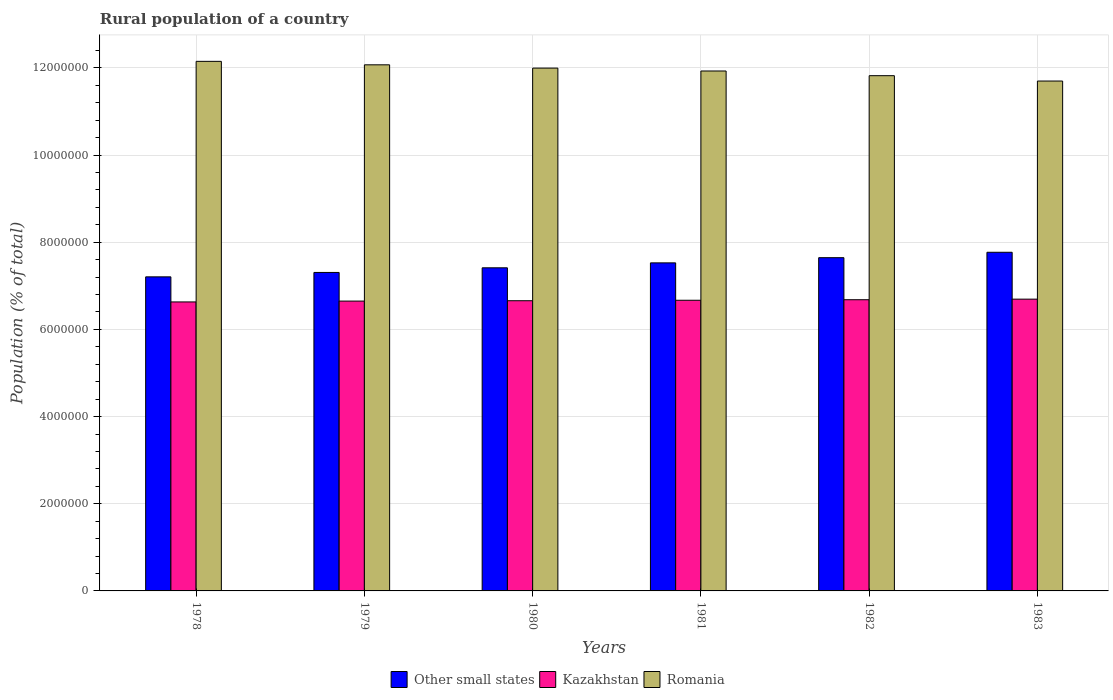How many groups of bars are there?
Make the answer very short. 6. Are the number of bars per tick equal to the number of legend labels?
Your response must be concise. Yes. What is the rural population in Other small states in 1982?
Your answer should be very brief. 7.65e+06. Across all years, what is the maximum rural population in Kazakhstan?
Provide a short and direct response. 6.69e+06. Across all years, what is the minimum rural population in Kazakhstan?
Offer a very short reply. 6.63e+06. In which year was the rural population in Other small states maximum?
Give a very brief answer. 1983. In which year was the rural population in Other small states minimum?
Your response must be concise. 1978. What is the total rural population in Kazakhstan in the graph?
Make the answer very short. 4.00e+07. What is the difference between the rural population in Romania in 1978 and that in 1979?
Ensure brevity in your answer.  7.97e+04. What is the difference between the rural population in Kazakhstan in 1981 and the rural population in Other small states in 1978?
Provide a succinct answer. -5.37e+05. What is the average rural population in Kazakhstan per year?
Offer a very short reply. 6.66e+06. In the year 1981, what is the difference between the rural population in Kazakhstan and rural population in Romania?
Ensure brevity in your answer.  -5.26e+06. In how many years, is the rural population in Kazakhstan greater than 400000 %?
Keep it short and to the point. 6. What is the ratio of the rural population in Other small states in 1979 to that in 1982?
Keep it short and to the point. 0.96. Is the rural population in Romania in 1978 less than that in 1983?
Give a very brief answer. No. Is the difference between the rural population in Kazakhstan in 1981 and 1982 greater than the difference between the rural population in Romania in 1981 and 1982?
Provide a short and direct response. No. What is the difference between the highest and the second highest rural population in Kazakhstan?
Make the answer very short. 1.34e+04. What is the difference between the highest and the lowest rural population in Romania?
Give a very brief answer. 4.52e+05. What does the 2nd bar from the left in 1983 represents?
Keep it short and to the point. Kazakhstan. What does the 1st bar from the right in 1983 represents?
Offer a very short reply. Romania. Does the graph contain any zero values?
Make the answer very short. No. Does the graph contain grids?
Provide a succinct answer. Yes. Where does the legend appear in the graph?
Ensure brevity in your answer.  Bottom center. How many legend labels are there?
Your answer should be very brief. 3. How are the legend labels stacked?
Offer a very short reply. Horizontal. What is the title of the graph?
Ensure brevity in your answer.  Rural population of a country. What is the label or title of the X-axis?
Make the answer very short. Years. What is the label or title of the Y-axis?
Your answer should be compact. Population (% of total). What is the Population (% of total) of Other small states in 1978?
Provide a succinct answer. 7.21e+06. What is the Population (% of total) in Kazakhstan in 1978?
Provide a succinct answer. 6.63e+06. What is the Population (% of total) in Romania in 1978?
Ensure brevity in your answer.  1.22e+07. What is the Population (% of total) of Other small states in 1979?
Offer a terse response. 7.31e+06. What is the Population (% of total) in Kazakhstan in 1979?
Provide a short and direct response. 6.65e+06. What is the Population (% of total) in Romania in 1979?
Offer a terse response. 1.21e+07. What is the Population (% of total) of Other small states in 1980?
Offer a very short reply. 7.41e+06. What is the Population (% of total) in Kazakhstan in 1980?
Keep it short and to the point. 6.66e+06. What is the Population (% of total) of Romania in 1980?
Ensure brevity in your answer.  1.20e+07. What is the Population (% of total) in Other small states in 1981?
Ensure brevity in your answer.  7.53e+06. What is the Population (% of total) of Kazakhstan in 1981?
Ensure brevity in your answer.  6.67e+06. What is the Population (% of total) of Romania in 1981?
Ensure brevity in your answer.  1.19e+07. What is the Population (% of total) in Other small states in 1982?
Your response must be concise. 7.65e+06. What is the Population (% of total) in Kazakhstan in 1982?
Provide a succinct answer. 6.68e+06. What is the Population (% of total) in Romania in 1982?
Offer a very short reply. 1.18e+07. What is the Population (% of total) in Other small states in 1983?
Provide a succinct answer. 7.77e+06. What is the Population (% of total) of Kazakhstan in 1983?
Give a very brief answer. 6.69e+06. What is the Population (% of total) of Romania in 1983?
Offer a very short reply. 1.17e+07. Across all years, what is the maximum Population (% of total) of Other small states?
Offer a very short reply. 7.77e+06. Across all years, what is the maximum Population (% of total) of Kazakhstan?
Your response must be concise. 6.69e+06. Across all years, what is the maximum Population (% of total) in Romania?
Give a very brief answer. 1.22e+07. Across all years, what is the minimum Population (% of total) of Other small states?
Give a very brief answer. 7.21e+06. Across all years, what is the minimum Population (% of total) in Kazakhstan?
Give a very brief answer. 6.63e+06. Across all years, what is the minimum Population (% of total) in Romania?
Provide a succinct answer. 1.17e+07. What is the total Population (% of total) in Other small states in the graph?
Provide a succinct answer. 4.49e+07. What is the total Population (% of total) in Kazakhstan in the graph?
Your answer should be very brief. 4.00e+07. What is the total Population (% of total) in Romania in the graph?
Make the answer very short. 7.17e+07. What is the difference between the Population (% of total) of Other small states in 1978 and that in 1979?
Provide a short and direct response. -1.01e+05. What is the difference between the Population (% of total) of Kazakhstan in 1978 and that in 1979?
Keep it short and to the point. -1.93e+04. What is the difference between the Population (% of total) of Romania in 1978 and that in 1979?
Keep it short and to the point. 7.97e+04. What is the difference between the Population (% of total) in Other small states in 1978 and that in 1980?
Keep it short and to the point. -2.07e+05. What is the difference between the Population (% of total) of Kazakhstan in 1978 and that in 1980?
Provide a succinct answer. -2.76e+04. What is the difference between the Population (% of total) in Romania in 1978 and that in 1980?
Provide a short and direct response. 1.55e+05. What is the difference between the Population (% of total) of Other small states in 1978 and that in 1981?
Make the answer very short. -3.21e+05. What is the difference between the Population (% of total) in Kazakhstan in 1978 and that in 1981?
Give a very brief answer. -3.86e+04. What is the difference between the Population (% of total) of Romania in 1978 and that in 1981?
Ensure brevity in your answer.  2.21e+05. What is the difference between the Population (% of total) of Other small states in 1978 and that in 1982?
Ensure brevity in your answer.  -4.40e+05. What is the difference between the Population (% of total) of Kazakhstan in 1978 and that in 1982?
Give a very brief answer. -5.05e+04. What is the difference between the Population (% of total) in Romania in 1978 and that in 1982?
Offer a terse response. 3.29e+05. What is the difference between the Population (% of total) of Other small states in 1978 and that in 1983?
Your answer should be very brief. -5.64e+05. What is the difference between the Population (% of total) of Kazakhstan in 1978 and that in 1983?
Make the answer very short. -6.39e+04. What is the difference between the Population (% of total) of Romania in 1978 and that in 1983?
Keep it short and to the point. 4.52e+05. What is the difference between the Population (% of total) of Other small states in 1979 and that in 1980?
Make the answer very short. -1.06e+05. What is the difference between the Population (% of total) in Kazakhstan in 1979 and that in 1980?
Your response must be concise. -8289. What is the difference between the Population (% of total) of Romania in 1979 and that in 1980?
Your response must be concise. 7.52e+04. What is the difference between the Population (% of total) of Other small states in 1979 and that in 1981?
Make the answer very short. -2.20e+05. What is the difference between the Population (% of total) of Kazakhstan in 1979 and that in 1981?
Your answer should be compact. -1.93e+04. What is the difference between the Population (% of total) of Romania in 1979 and that in 1981?
Offer a very short reply. 1.42e+05. What is the difference between the Population (% of total) of Other small states in 1979 and that in 1982?
Ensure brevity in your answer.  -3.39e+05. What is the difference between the Population (% of total) in Kazakhstan in 1979 and that in 1982?
Provide a short and direct response. -3.12e+04. What is the difference between the Population (% of total) of Romania in 1979 and that in 1982?
Keep it short and to the point. 2.49e+05. What is the difference between the Population (% of total) in Other small states in 1979 and that in 1983?
Offer a terse response. -4.63e+05. What is the difference between the Population (% of total) in Kazakhstan in 1979 and that in 1983?
Give a very brief answer. -4.46e+04. What is the difference between the Population (% of total) of Romania in 1979 and that in 1983?
Ensure brevity in your answer.  3.72e+05. What is the difference between the Population (% of total) in Other small states in 1980 and that in 1981?
Your response must be concise. -1.13e+05. What is the difference between the Population (% of total) of Kazakhstan in 1980 and that in 1981?
Offer a very short reply. -1.10e+04. What is the difference between the Population (% of total) of Romania in 1980 and that in 1981?
Ensure brevity in your answer.  6.63e+04. What is the difference between the Population (% of total) of Other small states in 1980 and that in 1982?
Keep it short and to the point. -2.33e+05. What is the difference between the Population (% of total) of Kazakhstan in 1980 and that in 1982?
Provide a succinct answer. -2.29e+04. What is the difference between the Population (% of total) of Romania in 1980 and that in 1982?
Offer a very short reply. 1.74e+05. What is the difference between the Population (% of total) of Other small states in 1980 and that in 1983?
Ensure brevity in your answer.  -3.56e+05. What is the difference between the Population (% of total) in Kazakhstan in 1980 and that in 1983?
Ensure brevity in your answer.  -3.63e+04. What is the difference between the Population (% of total) of Romania in 1980 and that in 1983?
Your answer should be compact. 2.97e+05. What is the difference between the Population (% of total) in Other small states in 1981 and that in 1982?
Offer a terse response. -1.19e+05. What is the difference between the Population (% of total) of Kazakhstan in 1981 and that in 1982?
Provide a short and direct response. -1.19e+04. What is the difference between the Population (% of total) in Romania in 1981 and that in 1982?
Offer a very short reply. 1.07e+05. What is the difference between the Population (% of total) in Other small states in 1981 and that in 1983?
Your response must be concise. -2.43e+05. What is the difference between the Population (% of total) in Kazakhstan in 1981 and that in 1983?
Keep it short and to the point. -2.53e+04. What is the difference between the Population (% of total) of Romania in 1981 and that in 1983?
Your answer should be compact. 2.30e+05. What is the difference between the Population (% of total) in Other small states in 1982 and that in 1983?
Offer a very short reply. -1.24e+05. What is the difference between the Population (% of total) in Kazakhstan in 1982 and that in 1983?
Provide a short and direct response. -1.34e+04. What is the difference between the Population (% of total) in Romania in 1982 and that in 1983?
Your answer should be compact. 1.23e+05. What is the difference between the Population (% of total) of Other small states in 1978 and the Population (% of total) of Kazakhstan in 1979?
Your response must be concise. 5.56e+05. What is the difference between the Population (% of total) in Other small states in 1978 and the Population (% of total) in Romania in 1979?
Your answer should be compact. -4.86e+06. What is the difference between the Population (% of total) of Kazakhstan in 1978 and the Population (% of total) of Romania in 1979?
Keep it short and to the point. -5.44e+06. What is the difference between the Population (% of total) of Other small states in 1978 and the Population (% of total) of Kazakhstan in 1980?
Ensure brevity in your answer.  5.48e+05. What is the difference between the Population (% of total) in Other small states in 1978 and the Population (% of total) in Romania in 1980?
Keep it short and to the point. -4.79e+06. What is the difference between the Population (% of total) of Kazakhstan in 1978 and the Population (% of total) of Romania in 1980?
Provide a succinct answer. -5.36e+06. What is the difference between the Population (% of total) of Other small states in 1978 and the Population (% of total) of Kazakhstan in 1981?
Your answer should be compact. 5.37e+05. What is the difference between the Population (% of total) in Other small states in 1978 and the Population (% of total) in Romania in 1981?
Your response must be concise. -4.72e+06. What is the difference between the Population (% of total) in Kazakhstan in 1978 and the Population (% of total) in Romania in 1981?
Provide a short and direct response. -5.30e+06. What is the difference between the Population (% of total) of Other small states in 1978 and the Population (% of total) of Kazakhstan in 1982?
Your answer should be compact. 5.25e+05. What is the difference between the Population (% of total) of Other small states in 1978 and the Population (% of total) of Romania in 1982?
Keep it short and to the point. -4.62e+06. What is the difference between the Population (% of total) of Kazakhstan in 1978 and the Population (% of total) of Romania in 1982?
Provide a short and direct response. -5.19e+06. What is the difference between the Population (% of total) of Other small states in 1978 and the Population (% of total) of Kazakhstan in 1983?
Offer a terse response. 5.12e+05. What is the difference between the Population (% of total) of Other small states in 1978 and the Population (% of total) of Romania in 1983?
Your answer should be very brief. -4.49e+06. What is the difference between the Population (% of total) in Kazakhstan in 1978 and the Population (% of total) in Romania in 1983?
Ensure brevity in your answer.  -5.07e+06. What is the difference between the Population (% of total) of Other small states in 1979 and the Population (% of total) of Kazakhstan in 1980?
Your answer should be very brief. 6.49e+05. What is the difference between the Population (% of total) in Other small states in 1979 and the Population (% of total) in Romania in 1980?
Provide a succinct answer. -4.69e+06. What is the difference between the Population (% of total) of Kazakhstan in 1979 and the Population (% of total) of Romania in 1980?
Your response must be concise. -5.35e+06. What is the difference between the Population (% of total) of Other small states in 1979 and the Population (% of total) of Kazakhstan in 1981?
Ensure brevity in your answer.  6.38e+05. What is the difference between the Population (% of total) in Other small states in 1979 and the Population (% of total) in Romania in 1981?
Your response must be concise. -4.62e+06. What is the difference between the Population (% of total) of Kazakhstan in 1979 and the Population (% of total) of Romania in 1981?
Offer a very short reply. -5.28e+06. What is the difference between the Population (% of total) of Other small states in 1979 and the Population (% of total) of Kazakhstan in 1982?
Your answer should be very brief. 6.26e+05. What is the difference between the Population (% of total) of Other small states in 1979 and the Population (% of total) of Romania in 1982?
Give a very brief answer. -4.51e+06. What is the difference between the Population (% of total) in Kazakhstan in 1979 and the Population (% of total) in Romania in 1982?
Offer a terse response. -5.17e+06. What is the difference between the Population (% of total) of Other small states in 1979 and the Population (% of total) of Kazakhstan in 1983?
Your answer should be compact. 6.13e+05. What is the difference between the Population (% of total) of Other small states in 1979 and the Population (% of total) of Romania in 1983?
Your answer should be very brief. -4.39e+06. What is the difference between the Population (% of total) in Kazakhstan in 1979 and the Population (% of total) in Romania in 1983?
Keep it short and to the point. -5.05e+06. What is the difference between the Population (% of total) in Other small states in 1980 and the Population (% of total) in Kazakhstan in 1981?
Make the answer very short. 7.44e+05. What is the difference between the Population (% of total) of Other small states in 1980 and the Population (% of total) of Romania in 1981?
Give a very brief answer. -4.52e+06. What is the difference between the Population (% of total) in Kazakhstan in 1980 and the Population (% of total) in Romania in 1981?
Your answer should be very brief. -5.27e+06. What is the difference between the Population (% of total) of Other small states in 1980 and the Population (% of total) of Kazakhstan in 1982?
Make the answer very short. 7.32e+05. What is the difference between the Population (% of total) of Other small states in 1980 and the Population (% of total) of Romania in 1982?
Your answer should be compact. -4.41e+06. What is the difference between the Population (% of total) of Kazakhstan in 1980 and the Population (% of total) of Romania in 1982?
Provide a succinct answer. -5.16e+06. What is the difference between the Population (% of total) in Other small states in 1980 and the Population (% of total) in Kazakhstan in 1983?
Give a very brief answer. 7.19e+05. What is the difference between the Population (% of total) in Other small states in 1980 and the Population (% of total) in Romania in 1983?
Provide a short and direct response. -4.29e+06. What is the difference between the Population (% of total) in Kazakhstan in 1980 and the Population (% of total) in Romania in 1983?
Your answer should be compact. -5.04e+06. What is the difference between the Population (% of total) of Other small states in 1981 and the Population (% of total) of Kazakhstan in 1982?
Your answer should be very brief. 8.46e+05. What is the difference between the Population (% of total) in Other small states in 1981 and the Population (% of total) in Romania in 1982?
Keep it short and to the point. -4.29e+06. What is the difference between the Population (% of total) of Kazakhstan in 1981 and the Population (% of total) of Romania in 1982?
Your answer should be compact. -5.15e+06. What is the difference between the Population (% of total) of Other small states in 1981 and the Population (% of total) of Kazakhstan in 1983?
Offer a terse response. 8.32e+05. What is the difference between the Population (% of total) of Other small states in 1981 and the Population (% of total) of Romania in 1983?
Keep it short and to the point. -4.17e+06. What is the difference between the Population (% of total) of Kazakhstan in 1981 and the Population (% of total) of Romania in 1983?
Your response must be concise. -5.03e+06. What is the difference between the Population (% of total) of Other small states in 1982 and the Population (% of total) of Kazakhstan in 1983?
Offer a very short reply. 9.52e+05. What is the difference between the Population (% of total) of Other small states in 1982 and the Population (% of total) of Romania in 1983?
Your answer should be very brief. -4.05e+06. What is the difference between the Population (% of total) of Kazakhstan in 1982 and the Population (% of total) of Romania in 1983?
Ensure brevity in your answer.  -5.02e+06. What is the average Population (% of total) in Other small states per year?
Keep it short and to the point. 7.48e+06. What is the average Population (% of total) in Kazakhstan per year?
Your answer should be compact. 6.66e+06. What is the average Population (% of total) of Romania per year?
Your answer should be compact. 1.19e+07. In the year 1978, what is the difference between the Population (% of total) in Other small states and Population (% of total) in Kazakhstan?
Make the answer very short. 5.76e+05. In the year 1978, what is the difference between the Population (% of total) in Other small states and Population (% of total) in Romania?
Provide a succinct answer. -4.94e+06. In the year 1978, what is the difference between the Population (% of total) of Kazakhstan and Population (% of total) of Romania?
Your response must be concise. -5.52e+06. In the year 1979, what is the difference between the Population (% of total) in Other small states and Population (% of total) in Kazakhstan?
Ensure brevity in your answer.  6.57e+05. In the year 1979, what is the difference between the Population (% of total) in Other small states and Population (% of total) in Romania?
Ensure brevity in your answer.  -4.76e+06. In the year 1979, what is the difference between the Population (% of total) of Kazakhstan and Population (% of total) of Romania?
Provide a succinct answer. -5.42e+06. In the year 1980, what is the difference between the Population (% of total) of Other small states and Population (% of total) of Kazakhstan?
Your answer should be very brief. 7.55e+05. In the year 1980, what is the difference between the Population (% of total) of Other small states and Population (% of total) of Romania?
Keep it short and to the point. -4.58e+06. In the year 1980, what is the difference between the Population (% of total) of Kazakhstan and Population (% of total) of Romania?
Your answer should be compact. -5.34e+06. In the year 1981, what is the difference between the Population (% of total) of Other small states and Population (% of total) of Kazakhstan?
Provide a succinct answer. 8.58e+05. In the year 1981, what is the difference between the Population (% of total) in Other small states and Population (% of total) in Romania?
Provide a succinct answer. -4.40e+06. In the year 1981, what is the difference between the Population (% of total) of Kazakhstan and Population (% of total) of Romania?
Ensure brevity in your answer.  -5.26e+06. In the year 1982, what is the difference between the Population (% of total) in Other small states and Population (% of total) in Kazakhstan?
Keep it short and to the point. 9.65e+05. In the year 1982, what is the difference between the Population (% of total) in Other small states and Population (% of total) in Romania?
Ensure brevity in your answer.  -4.18e+06. In the year 1982, what is the difference between the Population (% of total) of Kazakhstan and Population (% of total) of Romania?
Keep it short and to the point. -5.14e+06. In the year 1983, what is the difference between the Population (% of total) of Other small states and Population (% of total) of Kazakhstan?
Offer a terse response. 1.08e+06. In the year 1983, what is the difference between the Population (% of total) in Other small states and Population (% of total) in Romania?
Give a very brief answer. -3.93e+06. In the year 1983, what is the difference between the Population (% of total) of Kazakhstan and Population (% of total) of Romania?
Your response must be concise. -5.00e+06. What is the ratio of the Population (% of total) of Other small states in 1978 to that in 1979?
Provide a short and direct response. 0.99. What is the ratio of the Population (% of total) in Romania in 1978 to that in 1979?
Offer a terse response. 1.01. What is the ratio of the Population (% of total) in Other small states in 1978 to that in 1980?
Your answer should be very brief. 0.97. What is the ratio of the Population (% of total) in Kazakhstan in 1978 to that in 1980?
Provide a short and direct response. 1. What is the ratio of the Population (% of total) of Romania in 1978 to that in 1980?
Make the answer very short. 1.01. What is the ratio of the Population (% of total) of Other small states in 1978 to that in 1981?
Offer a terse response. 0.96. What is the ratio of the Population (% of total) in Kazakhstan in 1978 to that in 1981?
Provide a succinct answer. 0.99. What is the ratio of the Population (% of total) in Romania in 1978 to that in 1981?
Keep it short and to the point. 1.02. What is the ratio of the Population (% of total) in Other small states in 1978 to that in 1982?
Provide a succinct answer. 0.94. What is the ratio of the Population (% of total) in Romania in 1978 to that in 1982?
Ensure brevity in your answer.  1.03. What is the ratio of the Population (% of total) in Other small states in 1978 to that in 1983?
Provide a succinct answer. 0.93. What is the ratio of the Population (% of total) in Kazakhstan in 1978 to that in 1983?
Your answer should be very brief. 0.99. What is the ratio of the Population (% of total) in Romania in 1978 to that in 1983?
Your answer should be very brief. 1.04. What is the ratio of the Population (% of total) in Other small states in 1979 to that in 1980?
Make the answer very short. 0.99. What is the ratio of the Population (% of total) of Other small states in 1979 to that in 1981?
Your answer should be very brief. 0.97. What is the ratio of the Population (% of total) in Romania in 1979 to that in 1981?
Make the answer very short. 1.01. What is the ratio of the Population (% of total) of Other small states in 1979 to that in 1982?
Make the answer very short. 0.96. What is the ratio of the Population (% of total) of Kazakhstan in 1979 to that in 1982?
Offer a very short reply. 1. What is the ratio of the Population (% of total) of Romania in 1979 to that in 1982?
Your answer should be compact. 1.02. What is the ratio of the Population (% of total) in Other small states in 1979 to that in 1983?
Offer a very short reply. 0.94. What is the ratio of the Population (% of total) in Kazakhstan in 1979 to that in 1983?
Make the answer very short. 0.99. What is the ratio of the Population (% of total) of Romania in 1979 to that in 1983?
Give a very brief answer. 1.03. What is the ratio of the Population (% of total) in Other small states in 1980 to that in 1981?
Your answer should be very brief. 0.98. What is the ratio of the Population (% of total) of Romania in 1980 to that in 1981?
Give a very brief answer. 1.01. What is the ratio of the Population (% of total) in Other small states in 1980 to that in 1982?
Offer a very short reply. 0.97. What is the ratio of the Population (% of total) in Romania in 1980 to that in 1982?
Keep it short and to the point. 1.01. What is the ratio of the Population (% of total) of Other small states in 1980 to that in 1983?
Offer a terse response. 0.95. What is the ratio of the Population (% of total) in Kazakhstan in 1980 to that in 1983?
Give a very brief answer. 0.99. What is the ratio of the Population (% of total) of Romania in 1980 to that in 1983?
Your answer should be compact. 1.03. What is the ratio of the Population (% of total) in Other small states in 1981 to that in 1982?
Give a very brief answer. 0.98. What is the ratio of the Population (% of total) of Kazakhstan in 1981 to that in 1982?
Offer a very short reply. 1. What is the ratio of the Population (% of total) in Romania in 1981 to that in 1982?
Provide a succinct answer. 1.01. What is the ratio of the Population (% of total) in Other small states in 1981 to that in 1983?
Make the answer very short. 0.97. What is the ratio of the Population (% of total) in Kazakhstan in 1981 to that in 1983?
Your answer should be compact. 1. What is the ratio of the Population (% of total) in Romania in 1981 to that in 1983?
Your answer should be very brief. 1.02. What is the ratio of the Population (% of total) of Other small states in 1982 to that in 1983?
Make the answer very short. 0.98. What is the ratio of the Population (% of total) in Romania in 1982 to that in 1983?
Offer a very short reply. 1.01. What is the difference between the highest and the second highest Population (% of total) in Other small states?
Your answer should be compact. 1.24e+05. What is the difference between the highest and the second highest Population (% of total) in Kazakhstan?
Provide a succinct answer. 1.34e+04. What is the difference between the highest and the second highest Population (% of total) of Romania?
Provide a short and direct response. 7.97e+04. What is the difference between the highest and the lowest Population (% of total) in Other small states?
Your answer should be compact. 5.64e+05. What is the difference between the highest and the lowest Population (% of total) of Kazakhstan?
Offer a terse response. 6.39e+04. What is the difference between the highest and the lowest Population (% of total) in Romania?
Your answer should be very brief. 4.52e+05. 